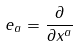Convert formula to latex. <formula><loc_0><loc_0><loc_500><loc_500>e _ { a } = \frac { \partial } { \partial x ^ { a } }</formula> 